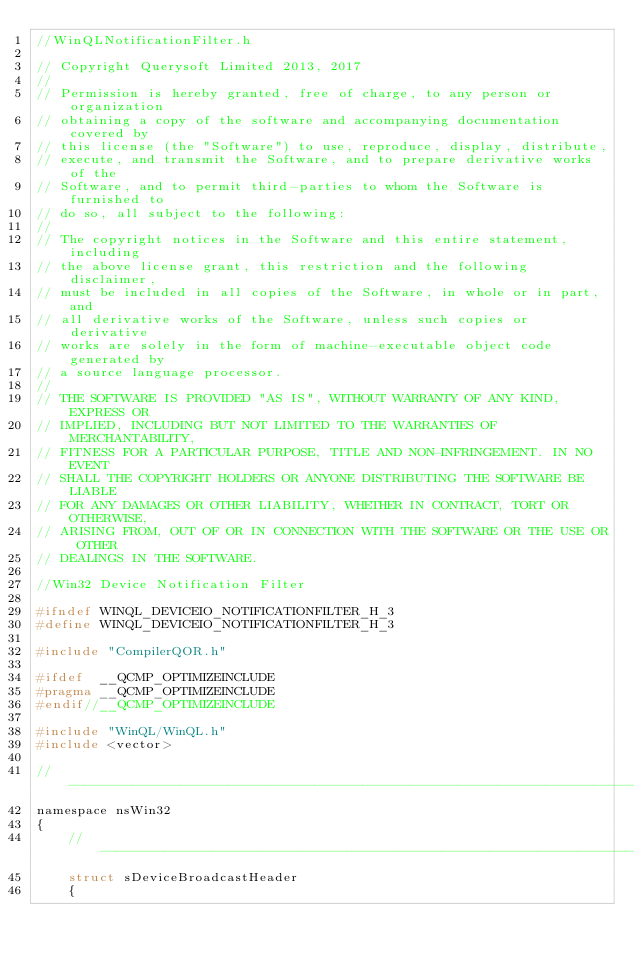<code> <loc_0><loc_0><loc_500><loc_500><_C_>//WinQLNotificationFilter.h

// Copyright Querysoft Limited 2013, 2017
//
// Permission is hereby granted, free of charge, to any person or organization
// obtaining a copy of the software and accompanying documentation covered by
// this license (the "Software") to use, reproduce, display, distribute,
// execute, and transmit the Software, and to prepare derivative works of the
// Software, and to permit third-parties to whom the Software is furnished to
// do so, all subject to the following:
// 
// The copyright notices in the Software and this entire statement, including
// the above license grant, this restriction and the following disclaimer,
// must be included in all copies of the Software, in whole or in part, and
// all derivative works of the Software, unless such copies or derivative
// works are solely in the form of machine-executable object code generated by
// a source language processor.
// 
// THE SOFTWARE IS PROVIDED "AS IS", WITHOUT WARRANTY OF ANY KIND, EXPRESS OR
// IMPLIED, INCLUDING BUT NOT LIMITED TO THE WARRANTIES OF MERCHANTABILITY,
// FITNESS FOR A PARTICULAR PURPOSE, TITLE AND NON-INFRINGEMENT. IN NO EVENT
// SHALL THE COPYRIGHT HOLDERS OR ANYONE DISTRIBUTING THE SOFTWARE BE LIABLE
// FOR ANY DAMAGES OR OTHER LIABILITY, WHETHER IN CONTRACT, TORT OR OTHERWISE,
// ARISING FROM, OUT OF OR IN CONNECTION WITH THE SOFTWARE OR THE USE OR OTHER
// DEALINGS IN THE SOFTWARE.

//Win32 Device Notification Filter

#ifndef WINQL_DEVICEIO_NOTIFICATIONFILTER_H_3
#define WINQL_DEVICEIO_NOTIFICATIONFILTER_H_3

#include "CompilerQOR.h"

#ifdef	__QCMP_OPTIMIZEINCLUDE
#pragma	__QCMP_OPTIMIZEINCLUDE
#endif//__QCMP_OPTIMIZEINCLUDE

#include "WinQL/WinQL.h"
#include <vector>

//--------------------------------------------------------------------------------
namespace nsWin32
{
	//--------------------------------------------------------------------------------
	struct sDeviceBroadcastHeader
	{</code> 